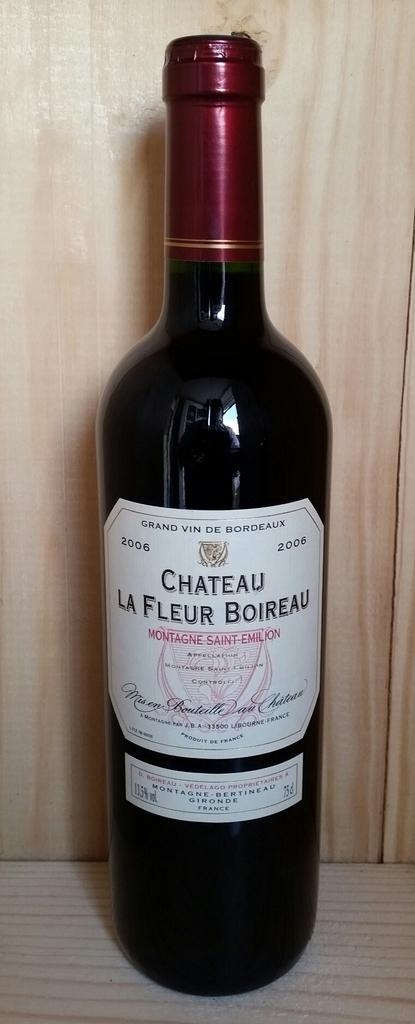Provide a one-sentence caption for the provided image. A bottle of Chateau La Fleur Boireau wine. 